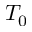<formula> <loc_0><loc_0><loc_500><loc_500>T _ { 0 }</formula> 